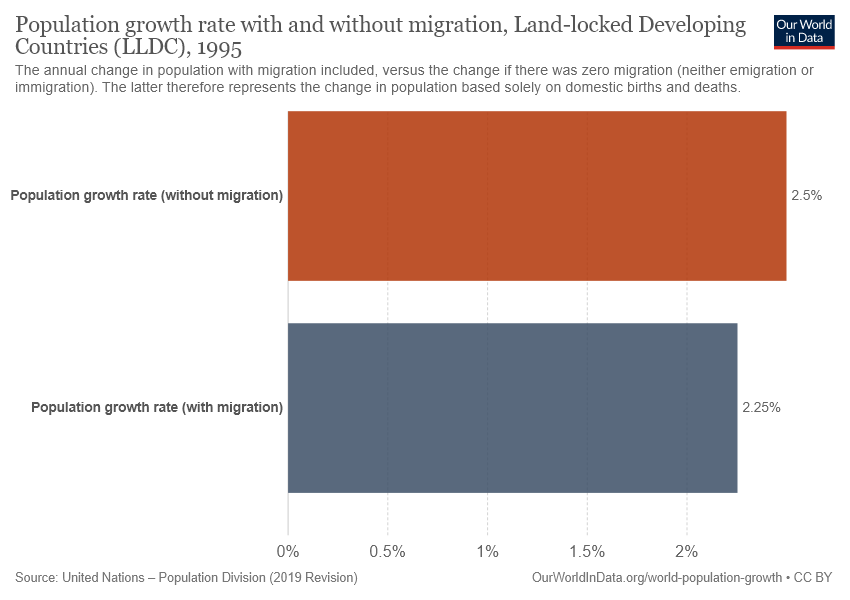Mention a couple of crucial points in this snapshot. The difference in value between Grey color and Orange color is 0.25. The orange color in the graph represents the population growth rate without migration, which is indicated by the increasing trend in the orange line over time. 